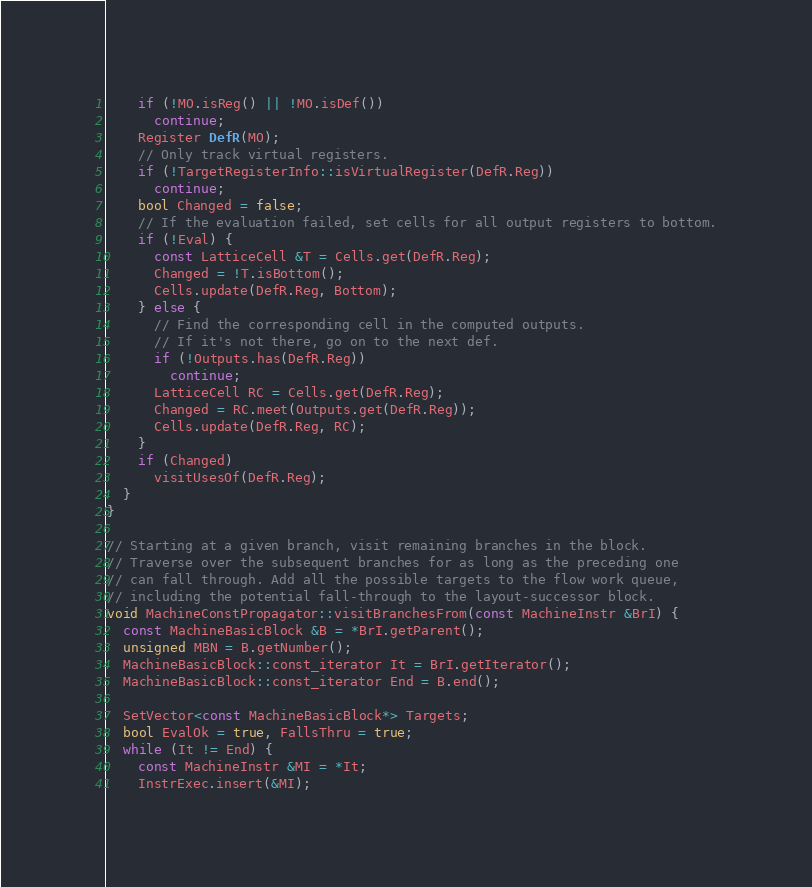<code> <loc_0><loc_0><loc_500><loc_500><_C++_>    if (!MO.isReg() || !MO.isDef())
      continue;
    Register DefR(MO);
    // Only track virtual registers.
    if (!TargetRegisterInfo::isVirtualRegister(DefR.Reg))
      continue;
    bool Changed = false;
    // If the evaluation failed, set cells for all output registers to bottom.
    if (!Eval) {
      const LatticeCell &T = Cells.get(DefR.Reg);
      Changed = !T.isBottom();
      Cells.update(DefR.Reg, Bottom);
    } else {
      // Find the corresponding cell in the computed outputs.
      // If it's not there, go on to the next def.
      if (!Outputs.has(DefR.Reg))
        continue;
      LatticeCell RC = Cells.get(DefR.Reg);
      Changed = RC.meet(Outputs.get(DefR.Reg));
      Cells.update(DefR.Reg, RC);
    }
    if (Changed)
      visitUsesOf(DefR.Reg);
  }
}

// Starting at a given branch, visit remaining branches in the block.
// Traverse over the subsequent branches for as long as the preceding one
// can fall through. Add all the possible targets to the flow work queue,
// including the potential fall-through to the layout-successor block.
void MachineConstPropagator::visitBranchesFrom(const MachineInstr &BrI) {
  const MachineBasicBlock &B = *BrI.getParent();
  unsigned MBN = B.getNumber();
  MachineBasicBlock::const_iterator It = BrI.getIterator();
  MachineBasicBlock::const_iterator End = B.end();

  SetVector<const MachineBasicBlock*> Targets;
  bool EvalOk = true, FallsThru = true;
  while (It != End) {
    const MachineInstr &MI = *It;
    InstrExec.insert(&MI);</code> 